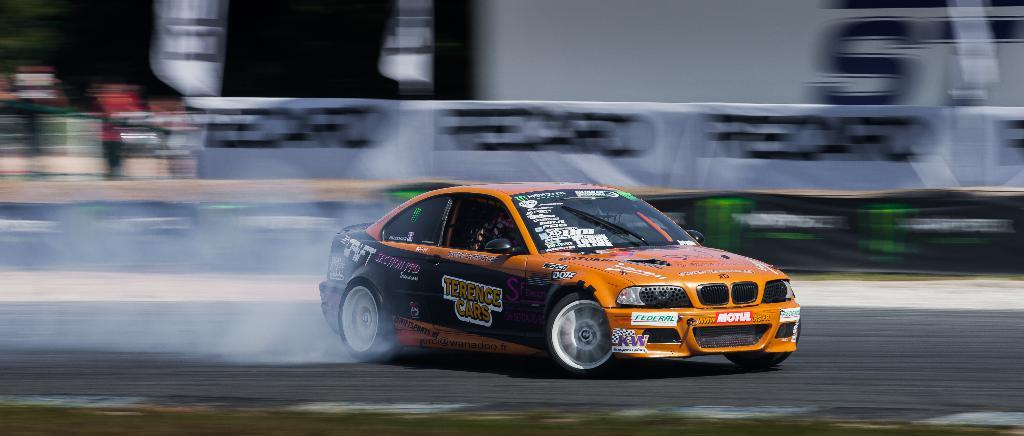What is the main subject of the image? The main subject of the image is a car. Where is the car located in the image? The car is on the road in the image. Can you describe the background of the image? The background of the image is blurred. What type of knowledge can be gained from the rain in the image? There is no rain present in the image, so no knowledge can be gained from it. 